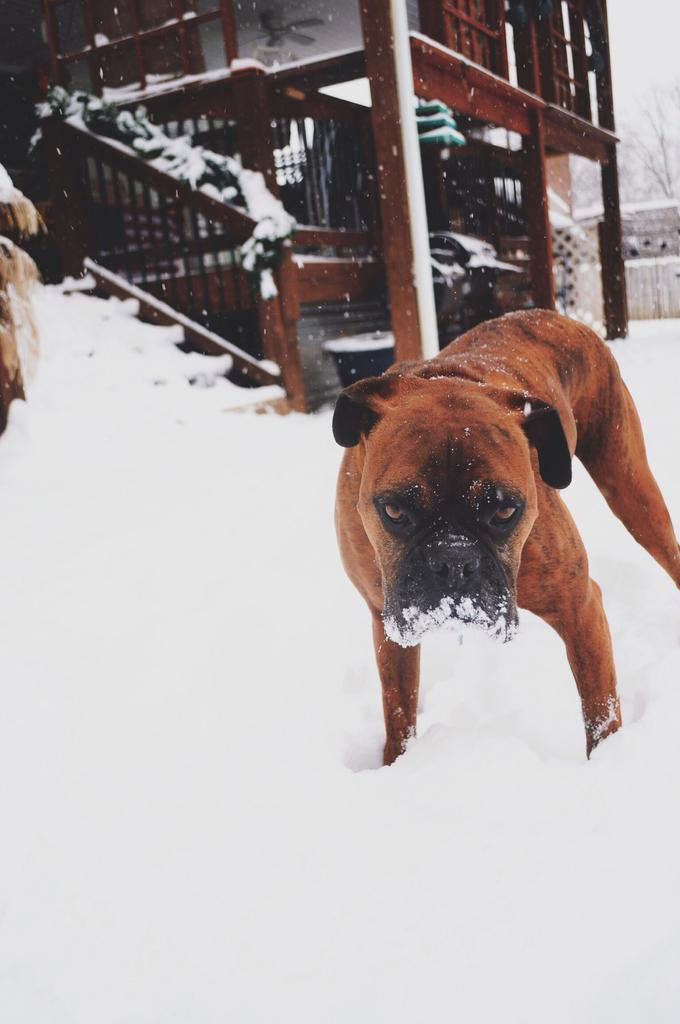What is the main subject in the foreground of the image? There is a dog in the foreground of the image. What type of weather condition is depicted in the image? There is snow at the bottom of the image. What can be seen in the background of the image? There are houses in the background of the image. What type of oatmeal is the dog eating in the image? There is no oatmeal present in the image; the dog is not eating anything. Can you see a toy that the dog is playing with in the image? There is no toy visible in the image. 